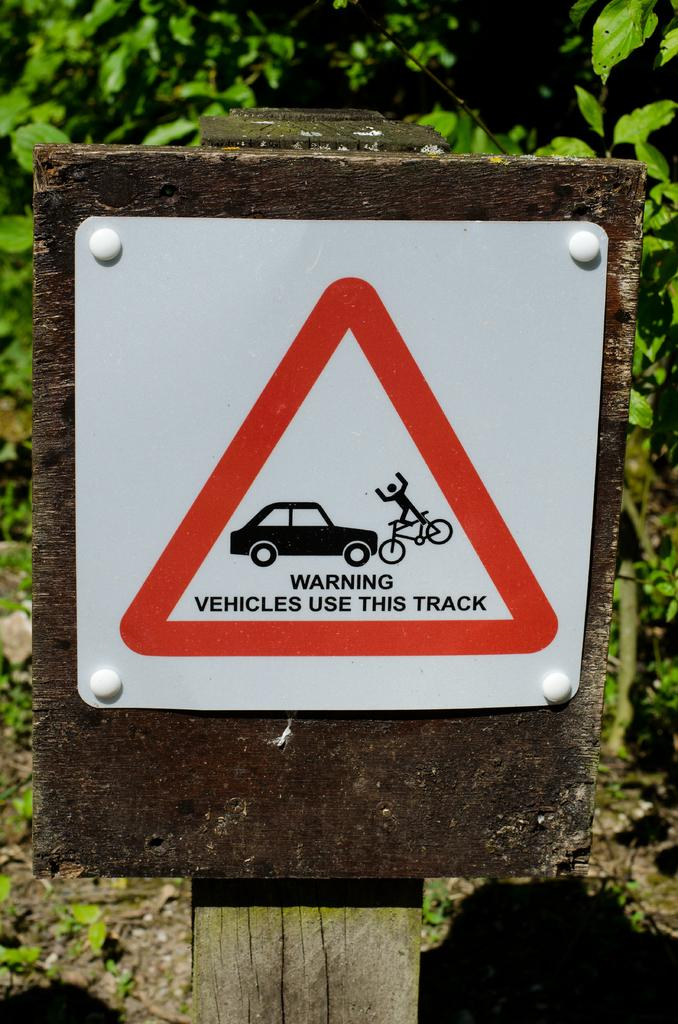What is the main object in the image? There is a sign board in the image. How is the sign board attached? The sign board is attached to a wooden board. What colors are used on the sign board? The sign board is in white, red, and black colors. What can be seen in the background of the image? There are trees visible in the background of the image. What grade is the church in the image? There is no church present in the image, so it is not possible to determine its grade. 